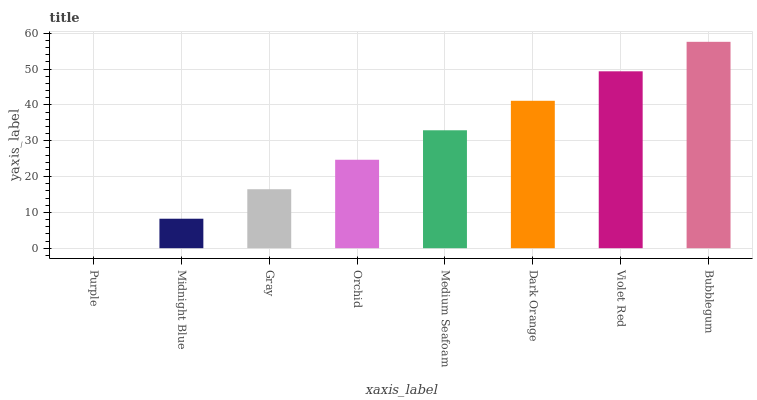Is Midnight Blue the minimum?
Answer yes or no. No. Is Midnight Blue the maximum?
Answer yes or no. No. Is Midnight Blue greater than Purple?
Answer yes or no. Yes. Is Purple less than Midnight Blue?
Answer yes or no. Yes. Is Purple greater than Midnight Blue?
Answer yes or no. No. Is Midnight Blue less than Purple?
Answer yes or no. No. Is Medium Seafoam the high median?
Answer yes or no. Yes. Is Orchid the low median?
Answer yes or no. Yes. Is Orchid the high median?
Answer yes or no. No. Is Medium Seafoam the low median?
Answer yes or no. No. 